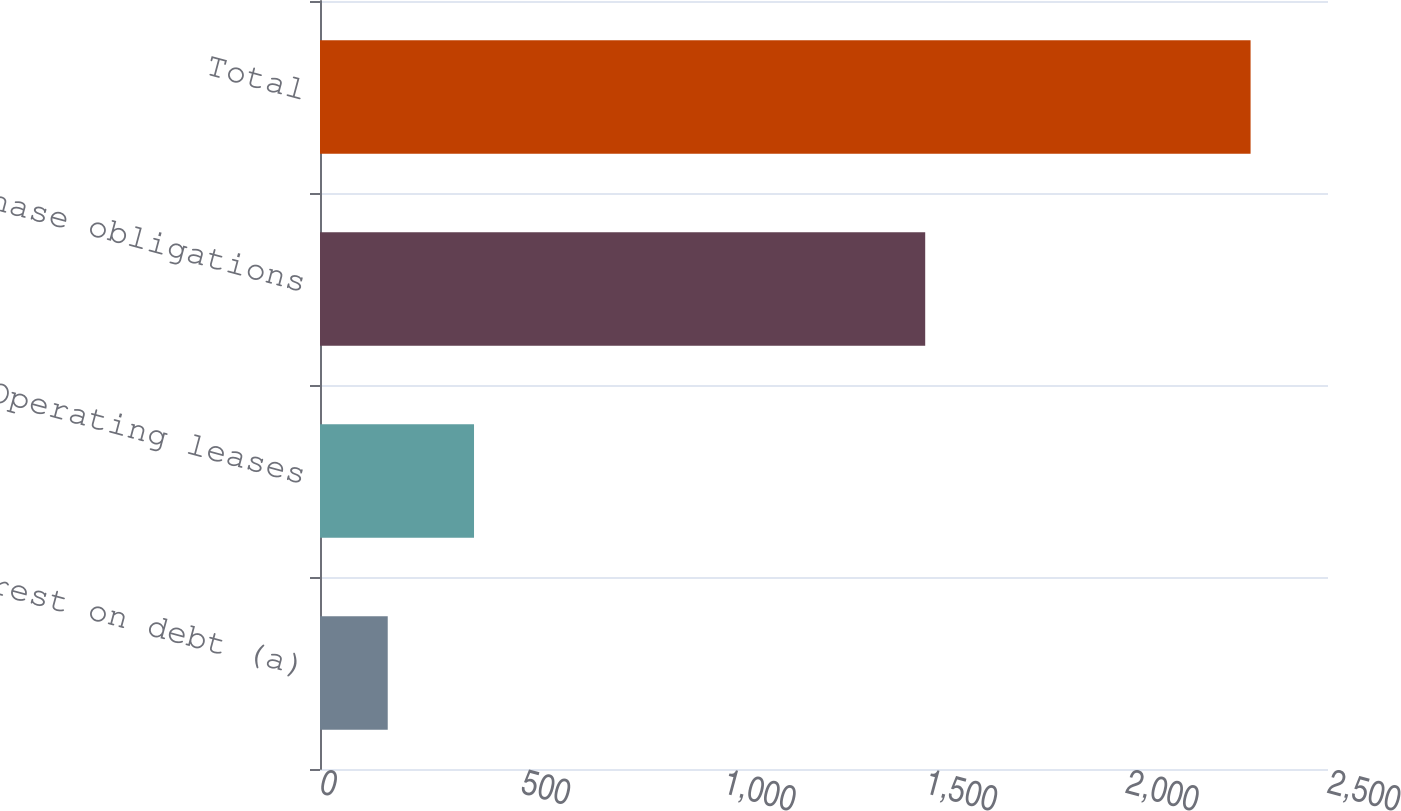<chart> <loc_0><loc_0><loc_500><loc_500><bar_chart><fcel>Interest on debt (a)<fcel>Operating leases<fcel>Purchase obligations<fcel>Total<nl><fcel>168<fcel>382<fcel>1501<fcel>2308<nl></chart> 